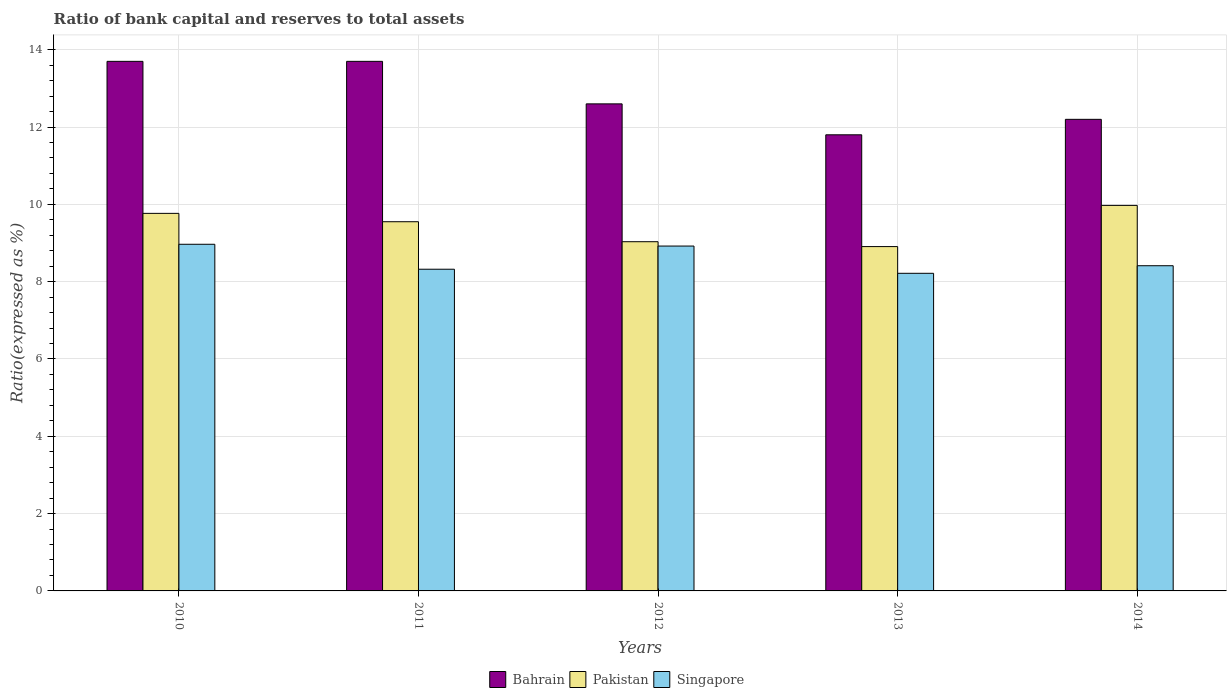Are the number of bars per tick equal to the number of legend labels?
Provide a succinct answer. Yes. Are the number of bars on each tick of the X-axis equal?
Offer a terse response. Yes. What is the ratio of bank capital and reserves to total assets in Pakistan in 2010?
Your answer should be very brief. 9.77. Across all years, what is the maximum ratio of bank capital and reserves to total assets in Bahrain?
Make the answer very short. 13.7. In which year was the ratio of bank capital and reserves to total assets in Pakistan maximum?
Provide a succinct answer. 2014. What is the difference between the ratio of bank capital and reserves to total assets in Pakistan in 2013 and that in 2014?
Your response must be concise. -1.07. What is the difference between the ratio of bank capital and reserves to total assets in Singapore in 2010 and the ratio of bank capital and reserves to total assets in Bahrain in 2013?
Offer a terse response. -2.83. What is the average ratio of bank capital and reserves to total assets in Bahrain per year?
Offer a very short reply. 12.8. In the year 2013, what is the difference between the ratio of bank capital and reserves to total assets in Pakistan and ratio of bank capital and reserves to total assets in Singapore?
Provide a short and direct response. 0.69. What is the ratio of the ratio of bank capital and reserves to total assets in Bahrain in 2012 to that in 2014?
Keep it short and to the point. 1.03. Is the ratio of bank capital and reserves to total assets in Bahrain in 2010 less than that in 2013?
Keep it short and to the point. No. Is the difference between the ratio of bank capital and reserves to total assets in Pakistan in 2012 and 2013 greater than the difference between the ratio of bank capital and reserves to total assets in Singapore in 2012 and 2013?
Offer a terse response. No. What is the difference between the highest and the second highest ratio of bank capital and reserves to total assets in Pakistan?
Provide a short and direct response. 0.21. What is the difference between the highest and the lowest ratio of bank capital and reserves to total assets in Pakistan?
Provide a short and direct response. 1.07. In how many years, is the ratio of bank capital and reserves to total assets in Bahrain greater than the average ratio of bank capital and reserves to total assets in Bahrain taken over all years?
Your answer should be compact. 2. What does the 3rd bar from the left in 2014 represents?
Provide a short and direct response. Singapore. What does the 1st bar from the right in 2013 represents?
Ensure brevity in your answer.  Singapore. Are all the bars in the graph horizontal?
Your response must be concise. No. What is the difference between two consecutive major ticks on the Y-axis?
Offer a terse response. 2. Are the values on the major ticks of Y-axis written in scientific E-notation?
Ensure brevity in your answer.  No. Does the graph contain any zero values?
Your response must be concise. No. How many legend labels are there?
Give a very brief answer. 3. How are the legend labels stacked?
Offer a terse response. Horizontal. What is the title of the graph?
Provide a short and direct response. Ratio of bank capital and reserves to total assets. Does "Rwanda" appear as one of the legend labels in the graph?
Offer a very short reply. No. What is the label or title of the Y-axis?
Make the answer very short. Ratio(expressed as %). What is the Ratio(expressed as %) in Pakistan in 2010?
Give a very brief answer. 9.77. What is the Ratio(expressed as %) in Singapore in 2010?
Provide a succinct answer. 8.97. What is the Ratio(expressed as %) in Bahrain in 2011?
Your answer should be compact. 13.7. What is the Ratio(expressed as %) of Pakistan in 2011?
Provide a short and direct response. 9.55. What is the Ratio(expressed as %) in Singapore in 2011?
Your response must be concise. 8.32. What is the Ratio(expressed as %) in Bahrain in 2012?
Your response must be concise. 12.6. What is the Ratio(expressed as %) in Pakistan in 2012?
Provide a succinct answer. 9.03. What is the Ratio(expressed as %) of Singapore in 2012?
Your answer should be compact. 8.92. What is the Ratio(expressed as %) of Bahrain in 2013?
Give a very brief answer. 11.8. What is the Ratio(expressed as %) of Pakistan in 2013?
Your response must be concise. 8.91. What is the Ratio(expressed as %) of Singapore in 2013?
Offer a terse response. 8.22. What is the Ratio(expressed as %) of Pakistan in 2014?
Make the answer very short. 9.97. What is the Ratio(expressed as %) in Singapore in 2014?
Offer a terse response. 8.41. Across all years, what is the maximum Ratio(expressed as %) of Bahrain?
Your answer should be compact. 13.7. Across all years, what is the maximum Ratio(expressed as %) in Pakistan?
Offer a very short reply. 9.97. Across all years, what is the maximum Ratio(expressed as %) of Singapore?
Offer a very short reply. 8.97. Across all years, what is the minimum Ratio(expressed as %) of Pakistan?
Provide a short and direct response. 8.91. Across all years, what is the minimum Ratio(expressed as %) in Singapore?
Provide a succinct answer. 8.22. What is the total Ratio(expressed as %) of Bahrain in the graph?
Give a very brief answer. 64. What is the total Ratio(expressed as %) in Pakistan in the graph?
Offer a very short reply. 47.23. What is the total Ratio(expressed as %) in Singapore in the graph?
Make the answer very short. 42.84. What is the difference between the Ratio(expressed as %) of Pakistan in 2010 and that in 2011?
Offer a very short reply. 0.22. What is the difference between the Ratio(expressed as %) of Singapore in 2010 and that in 2011?
Offer a very short reply. 0.65. What is the difference between the Ratio(expressed as %) of Pakistan in 2010 and that in 2012?
Offer a terse response. 0.73. What is the difference between the Ratio(expressed as %) of Singapore in 2010 and that in 2012?
Ensure brevity in your answer.  0.05. What is the difference between the Ratio(expressed as %) of Pakistan in 2010 and that in 2013?
Give a very brief answer. 0.86. What is the difference between the Ratio(expressed as %) of Singapore in 2010 and that in 2013?
Give a very brief answer. 0.75. What is the difference between the Ratio(expressed as %) in Pakistan in 2010 and that in 2014?
Ensure brevity in your answer.  -0.21. What is the difference between the Ratio(expressed as %) in Singapore in 2010 and that in 2014?
Ensure brevity in your answer.  0.56. What is the difference between the Ratio(expressed as %) in Pakistan in 2011 and that in 2012?
Your answer should be very brief. 0.52. What is the difference between the Ratio(expressed as %) in Singapore in 2011 and that in 2012?
Ensure brevity in your answer.  -0.6. What is the difference between the Ratio(expressed as %) in Pakistan in 2011 and that in 2013?
Offer a terse response. 0.64. What is the difference between the Ratio(expressed as %) in Singapore in 2011 and that in 2013?
Offer a terse response. 0.11. What is the difference between the Ratio(expressed as %) in Bahrain in 2011 and that in 2014?
Provide a succinct answer. 1.5. What is the difference between the Ratio(expressed as %) in Pakistan in 2011 and that in 2014?
Ensure brevity in your answer.  -0.42. What is the difference between the Ratio(expressed as %) in Singapore in 2011 and that in 2014?
Ensure brevity in your answer.  -0.09. What is the difference between the Ratio(expressed as %) of Pakistan in 2012 and that in 2013?
Your answer should be compact. 0.13. What is the difference between the Ratio(expressed as %) in Singapore in 2012 and that in 2013?
Give a very brief answer. 0.7. What is the difference between the Ratio(expressed as %) of Bahrain in 2012 and that in 2014?
Offer a terse response. 0.4. What is the difference between the Ratio(expressed as %) in Pakistan in 2012 and that in 2014?
Give a very brief answer. -0.94. What is the difference between the Ratio(expressed as %) of Singapore in 2012 and that in 2014?
Offer a terse response. 0.51. What is the difference between the Ratio(expressed as %) in Bahrain in 2013 and that in 2014?
Provide a succinct answer. -0.4. What is the difference between the Ratio(expressed as %) of Pakistan in 2013 and that in 2014?
Offer a very short reply. -1.07. What is the difference between the Ratio(expressed as %) of Singapore in 2013 and that in 2014?
Offer a very short reply. -0.2. What is the difference between the Ratio(expressed as %) of Bahrain in 2010 and the Ratio(expressed as %) of Pakistan in 2011?
Keep it short and to the point. 4.15. What is the difference between the Ratio(expressed as %) of Bahrain in 2010 and the Ratio(expressed as %) of Singapore in 2011?
Your answer should be compact. 5.38. What is the difference between the Ratio(expressed as %) of Pakistan in 2010 and the Ratio(expressed as %) of Singapore in 2011?
Ensure brevity in your answer.  1.44. What is the difference between the Ratio(expressed as %) of Bahrain in 2010 and the Ratio(expressed as %) of Pakistan in 2012?
Give a very brief answer. 4.67. What is the difference between the Ratio(expressed as %) of Bahrain in 2010 and the Ratio(expressed as %) of Singapore in 2012?
Keep it short and to the point. 4.78. What is the difference between the Ratio(expressed as %) in Pakistan in 2010 and the Ratio(expressed as %) in Singapore in 2012?
Your answer should be compact. 0.85. What is the difference between the Ratio(expressed as %) in Bahrain in 2010 and the Ratio(expressed as %) in Pakistan in 2013?
Provide a short and direct response. 4.79. What is the difference between the Ratio(expressed as %) in Bahrain in 2010 and the Ratio(expressed as %) in Singapore in 2013?
Your response must be concise. 5.48. What is the difference between the Ratio(expressed as %) of Pakistan in 2010 and the Ratio(expressed as %) of Singapore in 2013?
Your answer should be compact. 1.55. What is the difference between the Ratio(expressed as %) in Bahrain in 2010 and the Ratio(expressed as %) in Pakistan in 2014?
Provide a succinct answer. 3.73. What is the difference between the Ratio(expressed as %) in Bahrain in 2010 and the Ratio(expressed as %) in Singapore in 2014?
Give a very brief answer. 5.29. What is the difference between the Ratio(expressed as %) of Pakistan in 2010 and the Ratio(expressed as %) of Singapore in 2014?
Your answer should be compact. 1.35. What is the difference between the Ratio(expressed as %) in Bahrain in 2011 and the Ratio(expressed as %) in Pakistan in 2012?
Give a very brief answer. 4.67. What is the difference between the Ratio(expressed as %) in Bahrain in 2011 and the Ratio(expressed as %) in Singapore in 2012?
Ensure brevity in your answer.  4.78. What is the difference between the Ratio(expressed as %) of Pakistan in 2011 and the Ratio(expressed as %) of Singapore in 2012?
Your response must be concise. 0.63. What is the difference between the Ratio(expressed as %) in Bahrain in 2011 and the Ratio(expressed as %) in Pakistan in 2013?
Provide a succinct answer. 4.79. What is the difference between the Ratio(expressed as %) in Bahrain in 2011 and the Ratio(expressed as %) in Singapore in 2013?
Your response must be concise. 5.48. What is the difference between the Ratio(expressed as %) in Pakistan in 2011 and the Ratio(expressed as %) in Singapore in 2013?
Make the answer very short. 1.33. What is the difference between the Ratio(expressed as %) of Bahrain in 2011 and the Ratio(expressed as %) of Pakistan in 2014?
Offer a very short reply. 3.73. What is the difference between the Ratio(expressed as %) of Bahrain in 2011 and the Ratio(expressed as %) of Singapore in 2014?
Make the answer very short. 5.29. What is the difference between the Ratio(expressed as %) of Pakistan in 2011 and the Ratio(expressed as %) of Singapore in 2014?
Keep it short and to the point. 1.14. What is the difference between the Ratio(expressed as %) of Bahrain in 2012 and the Ratio(expressed as %) of Pakistan in 2013?
Your answer should be very brief. 3.69. What is the difference between the Ratio(expressed as %) of Bahrain in 2012 and the Ratio(expressed as %) of Singapore in 2013?
Give a very brief answer. 4.38. What is the difference between the Ratio(expressed as %) of Pakistan in 2012 and the Ratio(expressed as %) of Singapore in 2013?
Provide a succinct answer. 0.82. What is the difference between the Ratio(expressed as %) in Bahrain in 2012 and the Ratio(expressed as %) in Pakistan in 2014?
Offer a terse response. 2.63. What is the difference between the Ratio(expressed as %) of Bahrain in 2012 and the Ratio(expressed as %) of Singapore in 2014?
Make the answer very short. 4.19. What is the difference between the Ratio(expressed as %) in Pakistan in 2012 and the Ratio(expressed as %) in Singapore in 2014?
Your answer should be very brief. 0.62. What is the difference between the Ratio(expressed as %) in Bahrain in 2013 and the Ratio(expressed as %) in Pakistan in 2014?
Ensure brevity in your answer.  1.83. What is the difference between the Ratio(expressed as %) of Bahrain in 2013 and the Ratio(expressed as %) of Singapore in 2014?
Keep it short and to the point. 3.39. What is the difference between the Ratio(expressed as %) of Pakistan in 2013 and the Ratio(expressed as %) of Singapore in 2014?
Offer a terse response. 0.5. What is the average Ratio(expressed as %) in Pakistan per year?
Keep it short and to the point. 9.45. What is the average Ratio(expressed as %) in Singapore per year?
Your answer should be very brief. 8.57. In the year 2010, what is the difference between the Ratio(expressed as %) in Bahrain and Ratio(expressed as %) in Pakistan?
Your response must be concise. 3.93. In the year 2010, what is the difference between the Ratio(expressed as %) of Bahrain and Ratio(expressed as %) of Singapore?
Ensure brevity in your answer.  4.73. In the year 2010, what is the difference between the Ratio(expressed as %) of Pakistan and Ratio(expressed as %) of Singapore?
Give a very brief answer. 0.8. In the year 2011, what is the difference between the Ratio(expressed as %) in Bahrain and Ratio(expressed as %) in Pakistan?
Offer a terse response. 4.15. In the year 2011, what is the difference between the Ratio(expressed as %) of Bahrain and Ratio(expressed as %) of Singapore?
Your answer should be very brief. 5.38. In the year 2011, what is the difference between the Ratio(expressed as %) of Pakistan and Ratio(expressed as %) of Singapore?
Your response must be concise. 1.23. In the year 2012, what is the difference between the Ratio(expressed as %) in Bahrain and Ratio(expressed as %) in Pakistan?
Your answer should be compact. 3.57. In the year 2012, what is the difference between the Ratio(expressed as %) of Bahrain and Ratio(expressed as %) of Singapore?
Your response must be concise. 3.68. In the year 2012, what is the difference between the Ratio(expressed as %) in Pakistan and Ratio(expressed as %) in Singapore?
Provide a succinct answer. 0.11. In the year 2013, what is the difference between the Ratio(expressed as %) of Bahrain and Ratio(expressed as %) of Pakistan?
Ensure brevity in your answer.  2.89. In the year 2013, what is the difference between the Ratio(expressed as %) of Bahrain and Ratio(expressed as %) of Singapore?
Offer a terse response. 3.58. In the year 2013, what is the difference between the Ratio(expressed as %) in Pakistan and Ratio(expressed as %) in Singapore?
Ensure brevity in your answer.  0.69. In the year 2014, what is the difference between the Ratio(expressed as %) in Bahrain and Ratio(expressed as %) in Pakistan?
Keep it short and to the point. 2.23. In the year 2014, what is the difference between the Ratio(expressed as %) in Bahrain and Ratio(expressed as %) in Singapore?
Your answer should be compact. 3.79. In the year 2014, what is the difference between the Ratio(expressed as %) of Pakistan and Ratio(expressed as %) of Singapore?
Ensure brevity in your answer.  1.56. What is the ratio of the Ratio(expressed as %) of Pakistan in 2010 to that in 2011?
Make the answer very short. 1.02. What is the ratio of the Ratio(expressed as %) in Singapore in 2010 to that in 2011?
Keep it short and to the point. 1.08. What is the ratio of the Ratio(expressed as %) of Bahrain in 2010 to that in 2012?
Provide a succinct answer. 1.09. What is the ratio of the Ratio(expressed as %) in Pakistan in 2010 to that in 2012?
Your response must be concise. 1.08. What is the ratio of the Ratio(expressed as %) in Bahrain in 2010 to that in 2013?
Your response must be concise. 1.16. What is the ratio of the Ratio(expressed as %) of Pakistan in 2010 to that in 2013?
Provide a succinct answer. 1.1. What is the ratio of the Ratio(expressed as %) of Singapore in 2010 to that in 2013?
Give a very brief answer. 1.09. What is the ratio of the Ratio(expressed as %) in Bahrain in 2010 to that in 2014?
Your answer should be very brief. 1.12. What is the ratio of the Ratio(expressed as %) in Pakistan in 2010 to that in 2014?
Offer a very short reply. 0.98. What is the ratio of the Ratio(expressed as %) of Singapore in 2010 to that in 2014?
Provide a succinct answer. 1.07. What is the ratio of the Ratio(expressed as %) in Bahrain in 2011 to that in 2012?
Your answer should be compact. 1.09. What is the ratio of the Ratio(expressed as %) in Pakistan in 2011 to that in 2012?
Your answer should be very brief. 1.06. What is the ratio of the Ratio(expressed as %) of Singapore in 2011 to that in 2012?
Your response must be concise. 0.93. What is the ratio of the Ratio(expressed as %) in Bahrain in 2011 to that in 2013?
Your answer should be compact. 1.16. What is the ratio of the Ratio(expressed as %) in Pakistan in 2011 to that in 2013?
Ensure brevity in your answer.  1.07. What is the ratio of the Ratio(expressed as %) in Singapore in 2011 to that in 2013?
Your response must be concise. 1.01. What is the ratio of the Ratio(expressed as %) in Bahrain in 2011 to that in 2014?
Your answer should be very brief. 1.12. What is the ratio of the Ratio(expressed as %) in Pakistan in 2011 to that in 2014?
Keep it short and to the point. 0.96. What is the ratio of the Ratio(expressed as %) in Singapore in 2011 to that in 2014?
Your answer should be very brief. 0.99. What is the ratio of the Ratio(expressed as %) in Bahrain in 2012 to that in 2013?
Keep it short and to the point. 1.07. What is the ratio of the Ratio(expressed as %) of Pakistan in 2012 to that in 2013?
Your answer should be compact. 1.01. What is the ratio of the Ratio(expressed as %) of Singapore in 2012 to that in 2013?
Provide a succinct answer. 1.09. What is the ratio of the Ratio(expressed as %) of Bahrain in 2012 to that in 2014?
Make the answer very short. 1.03. What is the ratio of the Ratio(expressed as %) of Pakistan in 2012 to that in 2014?
Your answer should be very brief. 0.91. What is the ratio of the Ratio(expressed as %) in Singapore in 2012 to that in 2014?
Your response must be concise. 1.06. What is the ratio of the Ratio(expressed as %) in Bahrain in 2013 to that in 2014?
Ensure brevity in your answer.  0.97. What is the ratio of the Ratio(expressed as %) of Pakistan in 2013 to that in 2014?
Give a very brief answer. 0.89. What is the ratio of the Ratio(expressed as %) of Singapore in 2013 to that in 2014?
Your response must be concise. 0.98. What is the difference between the highest and the second highest Ratio(expressed as %) in Pakistan?
Make the answer very short. 0.21. What is the difference between the highest and the second highest Ratio(expressed as %) of Singapore?
Offer a very short reply. 0.05. What is the difference between the highest and the lowest Ratio(expressed as %) in Bahrain?
Your response must be concise. 1.9. What is the difference between the highest and the lowest Ratio(expressed as %) in Pakistan?
Make the answer very short. 1.07. What is the difference between the highest and the lowest Ratio(expressed as %) in Singapore?
Make the answer very short. 0.75. 